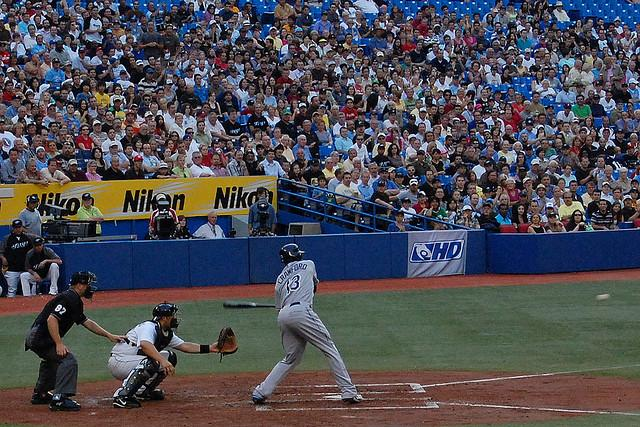The player swinging has the same dominant hand as what person? Please explain your reasoning. fred mcgriff. They are using the same hand. 